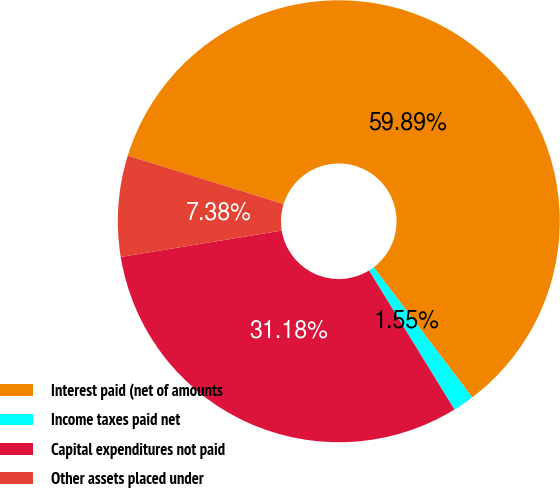Convert chart to OTSL. <chart><loc_0><loc_0><loc_500><loc_500><pie_chart><fcel>Interest paid (net of amounts<fcel>Income taxes paid net<fcel>Capital expenditures not paid<fcel>Other assets placed under<nl><fcel>59.88%<fcel>1.55%<fcel>31.18%<fcel>7.38%<nl></chart> 